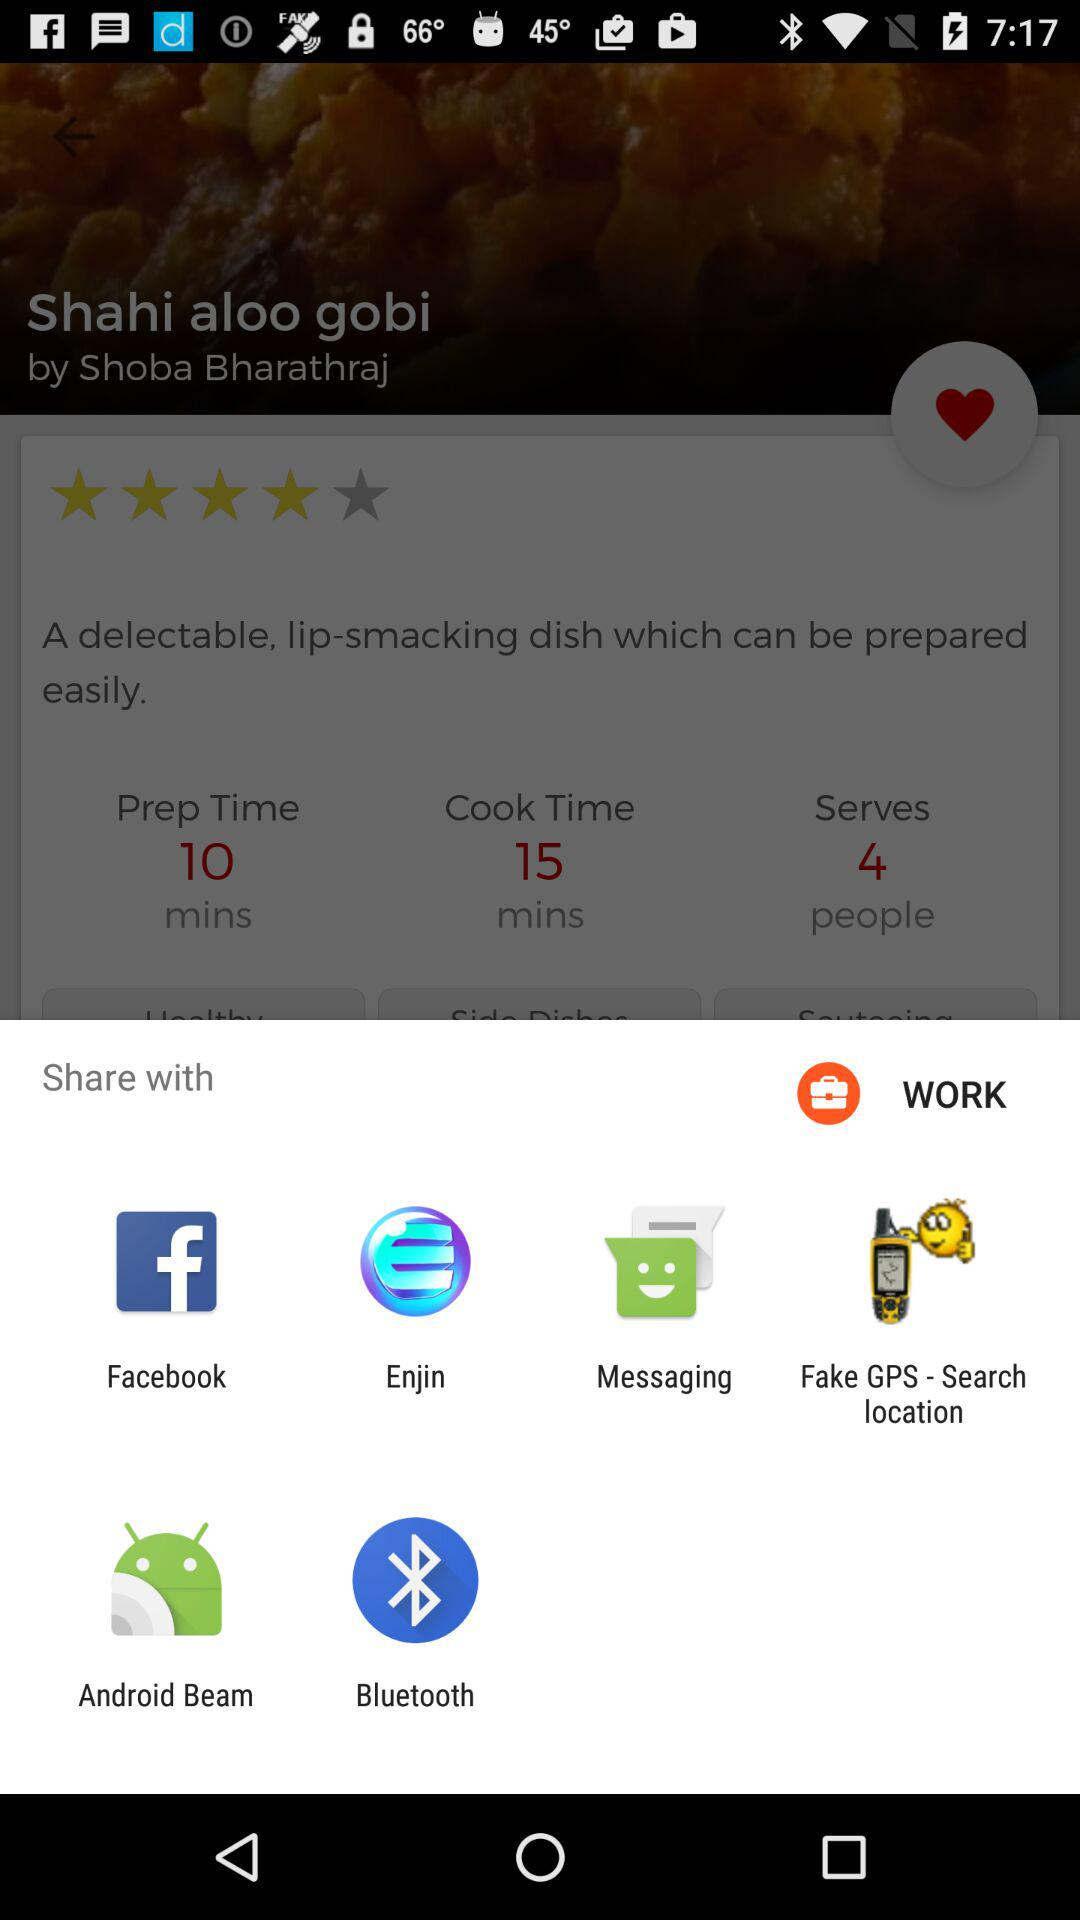Which applications can I use to share? The applications you can use to share are "Facebook", "Enjin", "Messaging", "Fake GPS - Search location", "Android Beam" and "Bluetooth". 